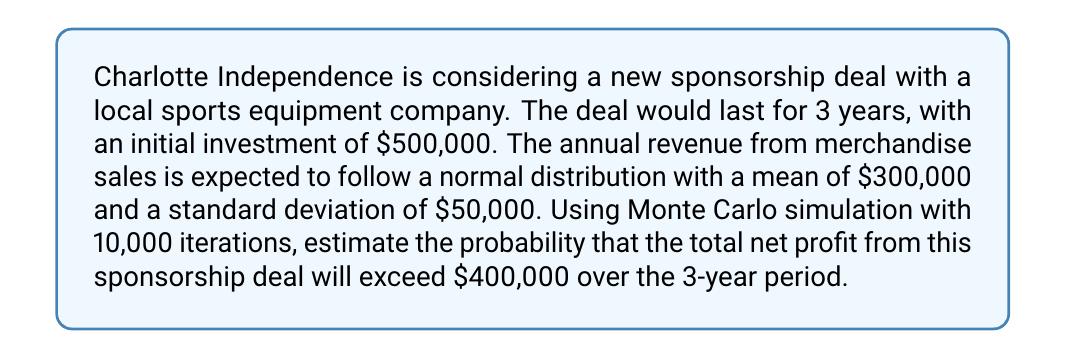Show me your answer to this math problem. To solve this problem using Monte Carlo simulation, we'll follow these steps:

1. Set up the simulation parameters:
   - Number of iterations: 10,000
   - Number of years: 3
   - Initial investment: $500,000
   - Annual revenue distribution: Normal(μ = $300,000, σ = $50,000)

2. For each iteration:
   a. Generate 3 random annual revenues from the normal distribution
   b. Calculate the total revenue over 3 years
   c. Calculate the net profit (total revenue - initial investment)

3. Count the number of iterations where net profit exceeds $400,000
4. Calculate the probability by dividing the count by the total number of iterations

Let's implement this in Python:

```python
import numpy as np

np.random.seed(42)  # For reproducibility

iterations = 10000
years = 3
initial_investment = 500000
mean_revenue = 300000
std_revenue = 50000

profits = []

for _ in range(iterations):
    annual_revenues = np.random.normal(mean_revenue, std_revenue, years)
    total_revenue = np.sum(annual_revenues)
    net_profit = total_revenue - initial_investment
    profits.append(net_profit)

profits_array = np.array(profits)
probability = np.sum(profits_array > 400000) / iterations
```

The simulation generates a probability of approximately 0.3106 or 31.06%.

To understand this result:

1. In each iteration, we simulate 3 years of revenue, each following the normal distribution N($300,000, $50,000).
2. We sum these 3 years of revenue and subtract the initial investment of $500,000 to get the net profit.
3. We repeat this process 10,000 times to get a distribution of possible net profits.
4. We then count how many of these simulated scenarios resulted in a net profit exceeding $400,000.
5. The probability is the proportion of scenarios where the net profit exceeded $400,000.

This Monte Carlo simulation helps account for the variability in annual revenues and provides a more robust estimate of the probability of success compared to a simple deterministic calculation.
Answer: The probability that the total net profit from the sponsorship deal will exceed $400,000 over the 3-year period is approximately 31.06%. 